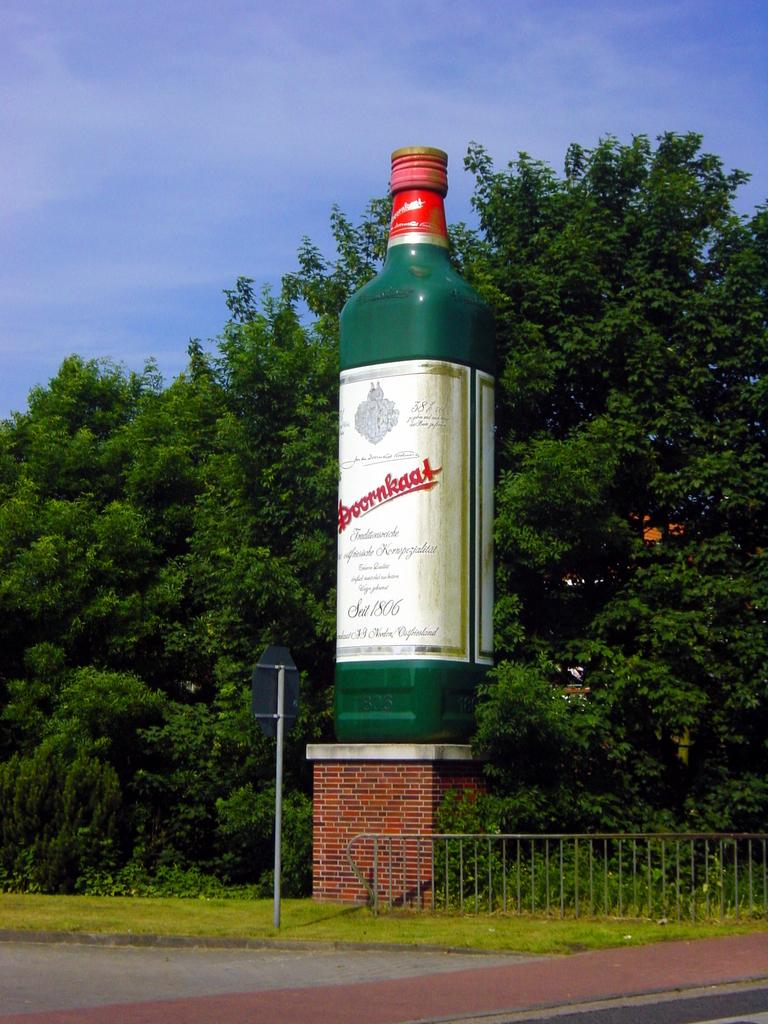<image>
Summarize the visual content of the image. A big bottle of Doornkat scotch, outside and about as tall as the talles tree in the picture. 